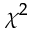<formula> <loc_0><loc_0><loc_500><loc_500>\chi ^ { 2 }</formula> 